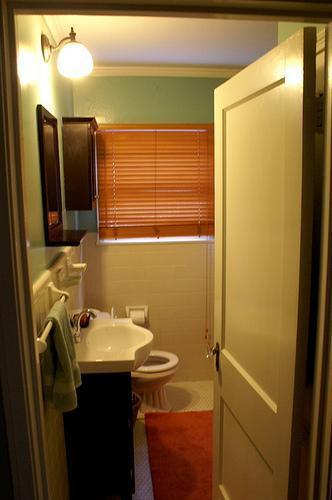How many towels are here?
Give a very brief answer. 1. 